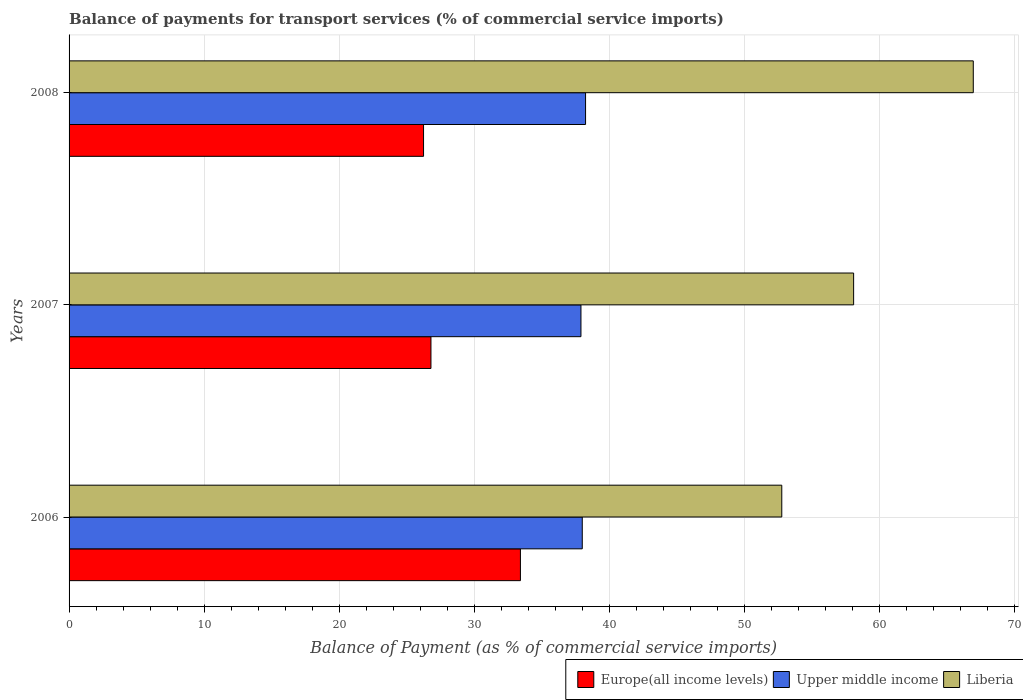How many different coloured bars are there?
Ensure brevity in your answer.  3. What is the label of the 1st group of bars from the top?
Provide a succinct answer. 2008. In how many cases, is the number of bars for a given year not equal to the number of legend labels?
Provide a short and direct response. 0. What is the balance of payments for transport services in Upper middle income in 2008?
Provide a succinct answer. 38.26. Across all years, what is the maximum balance of payments for transport services in Liberia?
Your answer should be very brief. 66.98. Across all years, what is the minimum balance of payments for transport services in Upper middle income?
Ensure brevity in your answer.  37.92. In which year was the balance of payments for transport services in Upper middle income maximum?
Your response must be concise. 2008. What is the total balance of payments for transport services in Europe(all income levels) in the graph?
Keep it short and to the point. 86.5. What is the difference between the balance of payments for transport services in Liberia in 2006 and that in 2008?
Ensure brevity in your answer.  -14.19. What is the difference between the balance of payments for transport services in Liberia in 2008 and the balance of payments for transport services in Upper middle income in 2007?
Your answer should be compact. 29.06. What is the average balance of payments for transport services in Europe(all income levels) per year?
Your answer should be compact. 28.83. In the year 2007, what is the difference between the balance of payments for transport services in Upper middle income and balance of payments for transport services in Europe(all income levels)?
Keep it short and to the point. 11.11. In how many years, is the balance of payments for transport services in Europe(all income levels) greater than 38 %?
Your answer should be compact. 0. What is the ratio of the balance of payments for transport services in Upper middle income in 2006 to that in 2008?
Make the answer very short. 0.99. Is the balance of payments for transport services in Europe(all income levels) in 2007 less than that in 2008?
Ensure brevity in your answer.  No. What is the difference between the highest and the second highest balance of payments for transport services in Upper middle income?
Provide a succinct answer. 0.24. What is the difference between the highest and the lowest balance of payments for transport services in Liberia?
Offer a terse response. 14.19. In how many years, is the balance of payments for transport services in Upper middle income greater than the average balance of payments for transport services in Upper middle income taken over all years?
Provide a short and direct response. 1. What does the 1st bar from the top in 2007 represents?
Your response must be concise. Liberia. What does the 1st bar from the bottom in 2008 represents?
Your answer should be very brief. Europe(all income levels). Are the values on the major ticks of X-axis written in scientific E-notation?
Make the answer very short. No. Does the graph contain any zero values?
Your answer should be very brief. No. Does the graph contain grids?
Your answer should be compact. Yes. Where does the legend appear in the graph?
Your answer should be compact. Bottom right. How many legend labels are there?
Your answer should be very brief. 3. How are the legend labels stacked?
Offer a very short reply. Horizontal. What is the title of the graph?
Offer a terse response. Balance of payments for transport services (% of commercial service imports). Does "Nicaragua" appear as one of the legend labels in the graph?
Ensure brevity in your answer.  No. What is the label or title of the X-axis?
Your answer should be compact. Balance of Payment (as % of commercial service imports). What is the label or title of the Y-axis?
Offer a very short reply. Years. What is the Balance of Payment (as % of commercial service imports) in Europe(all income levels) in 2006?
Provide a short and direct response. 33.44. What is the Balance of Payment (as % of commercial service imports) in Upper middle income in 2006?
Make the answer very short. 38.02. What is the Balance of Payment (as % of commercial service imports) of Liberia in 2006?
Your answer should be compact. 52.8. What is the Balance of Payment (as % of commercial service imports) in Europe(all income levels) in 2007?
Offer a very short reply. 26.81. What is the Balance of Payment (as % of commercial service imports) of Upper middle income in 2007?
Provide a succinct answer. 37.92. What is the Balance of Payment (as % of commercial service imports) in Liberia in 2007?
Keep it short and to the point. 58.12. What is the Balance of Payment (as % of commercial service imports) in Europe(all income levels) in 2008?
Offer a terse response. 26.26. What is the Balance of Payment (as % of commercial service imports) of Upper middle income in 2008?
Your response must be concise. 38.26. What is the Balance of Payment (as % of commercial service imports) in Liberia in 2008?
Provide a short and direct response. 66.98. Across all years, what is the maximum Balance of Payment (as % of commercial service imports) of Europe(all income levels)?
Your answer should be compact. 33.44. Across all years, what is the maximum Balance of Payment (as % of commercial service imports) in Upper middle income?
Give a very brief answer. 38.26. Across all years, what is the maximum Balance of Payment (as % of commercial service imports) of Liberia?
Keep it short and to the point. 66.98. Across all years, what is the minimum Balance of Payment (as % of commercial service imports) in Europe(all income levels)?
Your answer should be compact. 26.26. Across all years, what is the minimum Balance of Payment (as % of commercial service imports) of Upper middle income?
Your response must be concise. 37.92. Across all years, what is the minimum Balance of Payment (as % of commercial service imports) of Liberia?
Provide a short and direct response. 52.8. What is the total Balance of Payment (as % of commercial service imports) in Europe(all income levels) in the graph?
Offer a terse response. 86.5. What is the total Balance of Payment (as % of commercial service imports) of Upper middle income in the graph?
Make the answer very short. 114.2. What is the total Balance of Payment (as % of commercial service imports) of Liberia in the graph?
Keep it short and to the point. 177.9. What is the difference between the Balance of Payment (as % of commercial service imports) in Europe(all income levels) in 2006 and that in 2007?
Provide a succinct answer. 6.63. What is the difference between the Balance of Payment (as % of commercial service imports) in Upper middle income in 2006 and that in 2007?
Make the answer very short. 0.1. What is the difference between the Balance of Payment (as % of commercial service imports) of Liberia in 2006 and that in 2007?
Make the answer very short. -5.32. What is the difference between the Balance of Payment (as % of commercial service imports) of Europe(all income levels) in 2006 and that in 2008?
Provide a succinct answer. 7.18. What is the difference between the Balance of Payment (as % of commercial service imports) of Upper middle income in 2006 and that in 2008?
Offer a terse response. -0.24. What is the difference between the Balance of Payment (as % of commercial service imports) of Liberia in 2006 and that in 2008?
Ensure brevity in your answer.  -14.19. What is the difference between the Balance of Payment (as % of commercial service imports) in Europe(all income levels) in 2007 and that in 2008?
Ensure brevity in your answer.  0.55. What is the difference between the Balance of Payment (as % of commercial service imports) in Upper middle income in 2007 and that in 2008?
Offer a very short reply. -0.34. What is the difference between the Balance of Payment (as % of commercial service imports) in Liberia in 2007 and that in 2008?
Keep it short and to the point. -8.86. What is the difference between the Balance of Payment (as % of commercial service imports) in Europe(all income levels) in 2006 and the Balance of Payment (as % of commercial service imports) in Upper middle income in 2007?
Offer a terse response. -4.48. What is the difference between the Balance of Payment (as % of commercial service imports) of Europe(all income levels) in 2006 and the Balance of Payment (as % of commercial service imports) of Liberia in 2007?
Offer a terse response. -24.68. What is the difference between the Balance of Payment (as % of commercial service imports) of Upper middle income in 2006 and the Balance of Payment (as % of commercial service imports) of Liberia in 2007?
Keep it short and to the point. -20.1. What is the difference between the Balance of Payment (as % of commercial service imports) in Europe(all income levels) in 2006 and the Balance of Payment (as % of commercial service imports) in Upper middle income in 2008?
Your response must be concise. -4.83. What is the difference between the Balance of Payment (as % of commercial service imports) of Europe(all income levels) in 2006 and the Balance of Payment (as % of commercial service imports) of Liberia in 2008?
Offer a very short reply. -33.55. What is the difference between the Balance of Payment (as % of commercial service imports) in Upper middle income in 2006 and the Balance of Payment (as % of commercial service imports) in Liberia in 2008?
Keep it short and to the point. -28.97. What is the difference between the Balance of Payment (as % of commercial service imports) in Europe(all income levels) in 2007 and the Balance of Payment (as % of commercial service imports) in Upper middle income in 2008?
Your response must be concise. -11.45. What is the difference between the Balance of Payment (as % of commercial service imports) in Europe(all income levels) in 2007 and the Balance of Payment (as % of commercial service imports) in Liberia in 2008?
Your response must be concise. -40.18. What is the difference between the Balance of Payment (as % of commercial service imports) in Upper middle income in 2007 and the Balance of Payment (as % of commercial service imports) in Liberia in 2008?
Offer a very short reply. -29.06. What is the average Balance of Payment (as % of commercial service imports) of Europe(all income levels) per year?
Keep it short and to the point. 28.83. What is the average Balance of Payment (as % of commercial service imports) in Upper middle income per year?
Your response must be concise. 38.07. What is the average Balance of Payment (as % of commercial service imports) of Liberia per year?
Ensure brevity in your answer.  59.3. In the year 2006, what is the difference between the Balance of Payment (as % of commercial service imports) in Europe(all income levels) and Balance of Payment (as % of commercial service imports) in Upper middle income?
Offer a terse response. -4.58. In the year 2006, what is the difference between the Balance of Payment (as % of commercial service imports) of Europe(all income levels) and Balance of Payment (as % of commercial service imports) of Liberia?
Provide a succinct answer. -19.36. In the year 2006, what is the difference between the Balance of Payment (as % of commercial service imports) of Upper middle income and Balance of Payment (as % of commercial service imports) of Liberia?
Provide a short and direct response. -14.78. In the year 2007, what is the difference between the Balance of Payment (as % of commercial service imports) in Europe(all income levels) and Balance of Payment (as % of commercial service imports) in Upper middle income?
Your answer should be very brief. -11.11. In the year 2007, what is the difference between the Balance of Payment (as % of commercial service imports) of Europe(all income levels) and Balance of Payment (as % of commercial service imports) of Liberia?
Your answer should be compact. -31.31. In the year 2007, what is the difference between the Balance of Payment (as % of commercial service imports) in Upper middle income and Balance of Payment (as % of commercial service imports) in Liberia?
Your answer should be very brief. -20.2. In the year 2008, what is the difference between the Balance of Payment (as % of commercial service imports) of Europe(all income levels) and Balance of Payment (as % of commercial service imports) of Upper middle income?
Give a very brief answer. -12. In the year 2008, what is the difference between the Balance of Payment (as % of commercial service imports) in Europe(all income levels) and Balance of Payment (as % of commercial service imports) in Liberia?
Your response must be concise. -40.72. In the year 2008, what is the difference between the Balance of Payment (as % of commercial service imports) in Upper middle income and Balance of Payment (as % of commercial service imports) in Liberia?
Make the answer very short. -28.72. What is the ratio of the Balance of Payment (as % of commercial service imports) in Europe(all income levels) in 2006 to that in 2007?
Make the answer very short. 1.25. What is the ratio of the Balance of Payment (as % of commercial service imports) of Upper middle income in 2006 to that in 2007?
Provide a succinct answer. 1. What is the ratio of the Balance of Payment (as % of commercial service imports) in Liberia in 2006 to that in 2007?
Offer a very short reply. 0.91. What is the ratio of the Balance of Payment (as % of commercial service imports) of Europe(all income levels) in 2006 to that in 2008?
Your answer should be very brief. 1.27. What is the ratio of the Balance of Payment (as % of commercial service imports) in Upper middle income in 2006 to that in 2008?
Make the answer very short. 0.99. What is the ratio of the Balance of Payment (as % of commercial service imports) in Liberia in 2006 to that in 2008?
Ensure brevity in your answer.  0.79. What is the ratio of the Balance of Payment (as % of commercial service imports) in Europe(all income levels) in 2007 to that in 2008?
Keep it short and to the point. 1.02. What is the ratio of the Balance of Payment (as % of commercial service imports) of Upper middle income in 2007 to that in 2008?
Your answer should be very brief. 0.99. What is the ratio of the Balance of Payment (as % of commercial service imports) of Liberia in 2007 to that in 2008?
Offer a terse response. 0.87. What is the difference between the highest and the second highest Balance of Payment (as % of commercial service imports) of Europe(all income levels)?
Your response must be concise. 6.63. What is the difference between the highest and the second highest Balance of Payment (as % of commercial service imports) in Upper middle income?
Offer a terse response. 0.24. What is the difference between the highest and the second highest Balance of Payment (as % of commercial service imports) in Liberia?
Offer a very short reply. 8.86. What is the difference between the highest and the lowest Balance of Payment (as % of commercial service imports) in Europe(all income levels)?
Offer a very short reply. 7.18. What is the difference between the highest and the lowest Balance of Payment (as % of commercial service imports) in Upper middle income?
Ensure brevity in your answer.  0.34. What is the difference between the highest and the lowest Balance of Payment (as % of commercial service imports) of Liberia?
Give a very brief answer. 14.19. 